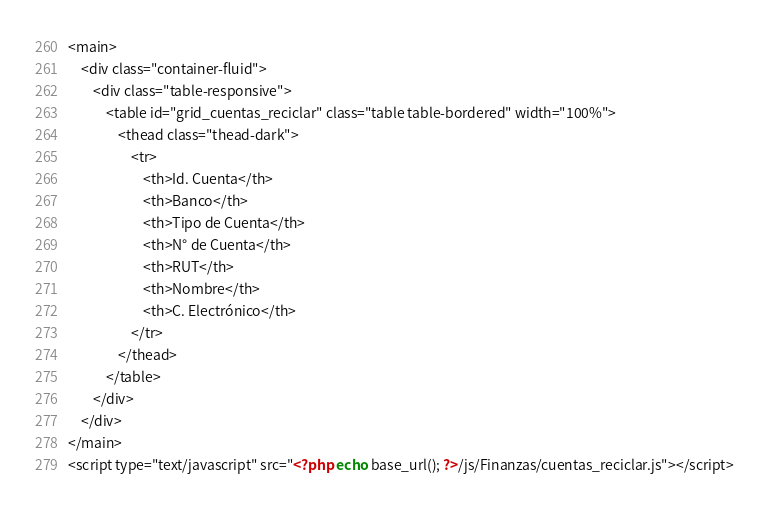Convert code to text. <code><loc_0><loc_0><loc_500><loc_500><_PHP_><main>
    <div class="container-fluid">
		<div class="table-responsive">
            <table id="grid_cuentas_reciclar" class="table table-bordered" width="100%">
                <thead class="thead-dark">
                    <tr>
                    	<th>Id. Cuenta</th>
                        <th>Banco</th>
                        <th>Tipo de Cuenta</th>
                        <th>N° de Cuenta</th>
                        <th>RUT</th>
                        <th>Nombre</th>
                        <th>C. Electrónico</th>
                    </tr>
                </thead>
            </table> 
        </div>
	</div>
</main>
<script type="text/javascript" src="<?php echo base_url(); ?>/js/Finanzas/cuentas_reciclar.js"></script></code> 